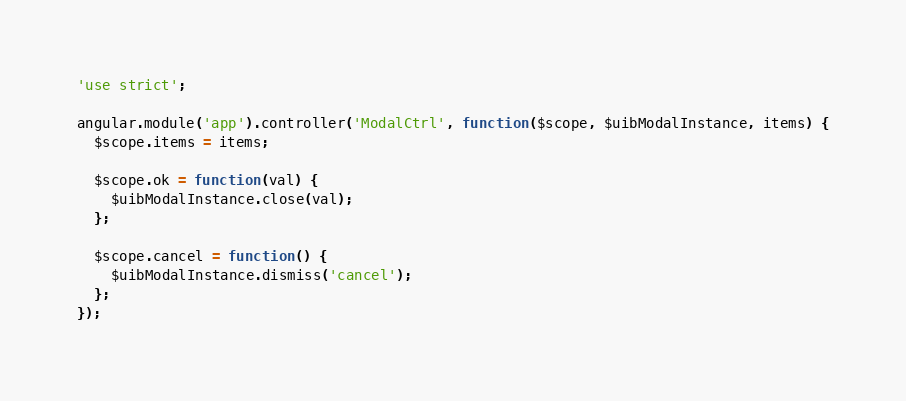Convert code to text. <code><loc_0><loc_0><loc_500><loc_500><_JavaScript_>'use strict';

angular.module('app').controller('ModalCtrl', function($scope, $uibModalInstance, items) {
  $scope.items = items;

  $scope.ok = function(val) {
    $uibModalInstance.close(val);
  };

  $scope.cancel = function() {
    $uibModalInstance.dismiss('cancel');
  };
});
</code> 